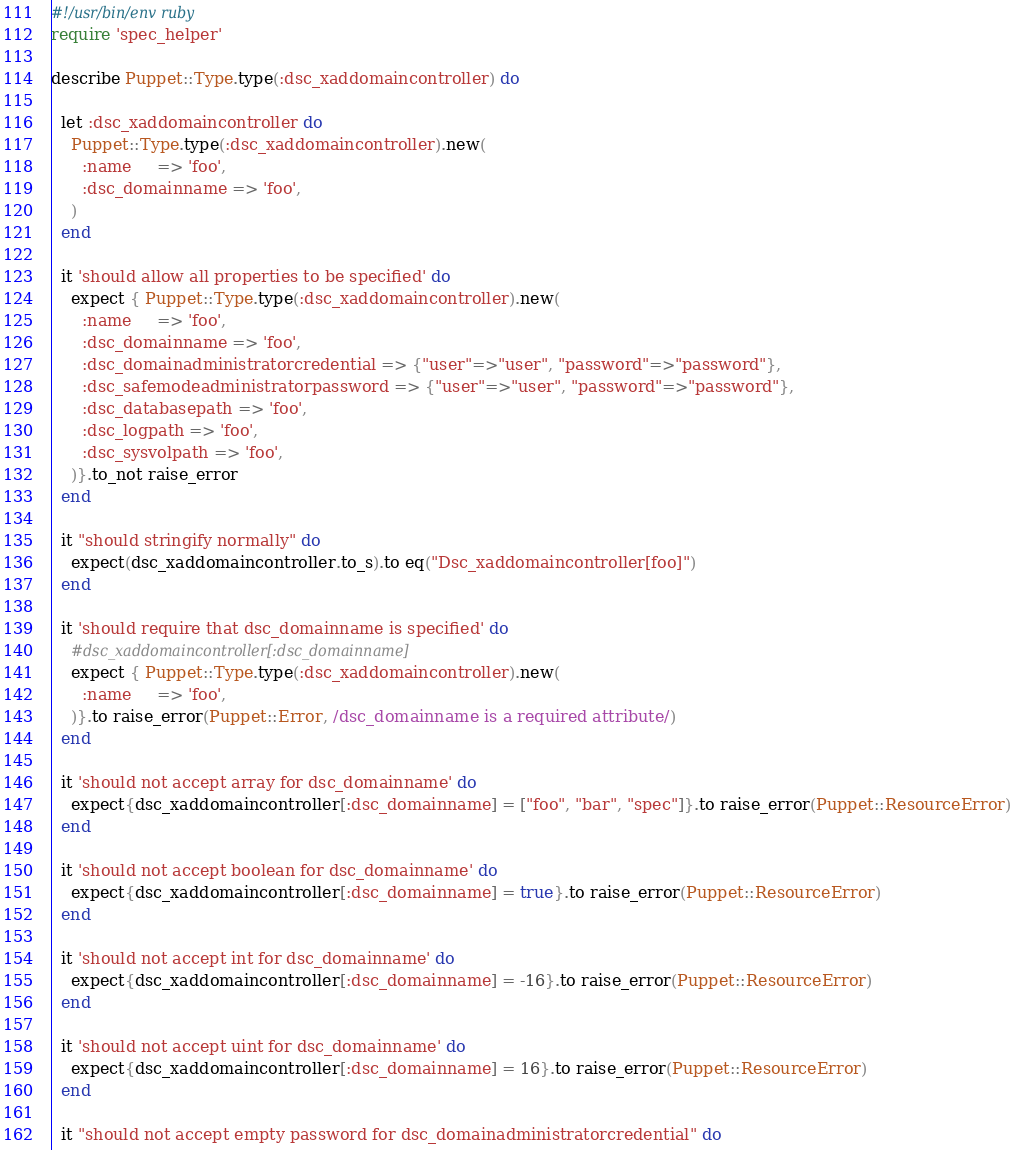<code> <loc_0><loc_0><loc_500><loc_500><_Ruby_>#!/usr/bin/env ruby
require 'spec_helper'

describe Puppet::Type.type(:dsc_xaddomaincontroller) do

  let :dsc_xaddomaincontroller do
    Puppet::Type.type(:dsc_xaddomaincontroller).new(
      :name     => 'foo',
      :dsc_domainname => 'foo',
    )
  end

  it 'should allow all properties to be specified' do
    expect { Puppet::Type.type(:dsc_xaddomaincontroller).new(
      :name     => 'foo',
      :dsc_domainname => 'foo',
      :dsc_domainadministratorcredential => {"user"=>"user", "password"=>"password"},
      :dsc_safemodeadministratorpassword => {"user"=>"user", "password"=>"password"},
      :dsc_databasepath => 'foo',
      :dsc_logpath => 'foo',
      :dsc_sysvolpath => 'foo',
    )}.to_not raise_error
  end

  it "should stringify normally" do
    expect(dsc_xaddomaincontroller.to_s).to eq("Dsc_xaddomaincontroller[foo]")
  end

  it 'should require that dsc_domainname is specified' do
    #dsc_xaddomaincontroller[:dsc_domainname]
    expect { Puppet::Type.type(:dsc_xaddomaincontroller).new(
      :name     => 'foo',
    )}.to raise_error(Puppet::Error, /dsc_domainname is a required attribute/)
  end

  it 'should not accept array for dsc_domainname' do
    expect{dsc_xaddomaincontroller[:dsc_domainname] = ["foo", "bar", "spec"]}.to raise_error(Puppet::ResourceError)
  end

  it 'should not accept boolean for dsc_domainname' do
    expect{dsc_xaddomaincontroller[:dsc_domainname] = true}.to raise_error(Puppet::ResourceError)
  end

  it 'should not accept int for dsc_domainname' do
    expect{dsc_xaddomaincontroller[:dsc_domainname] = -16}.to raise_error(Puppet::ResourceError)
  end

  it 'should not accept uint for dsc_domainname' do
    expect{dsc_xaddomaincontroller[:dsc_domainname] = 16}.to raise_error(Puppet::ResourceError)
  end

  it "should not accept empty password for dsc_domainadministratorcredential" do</code> 